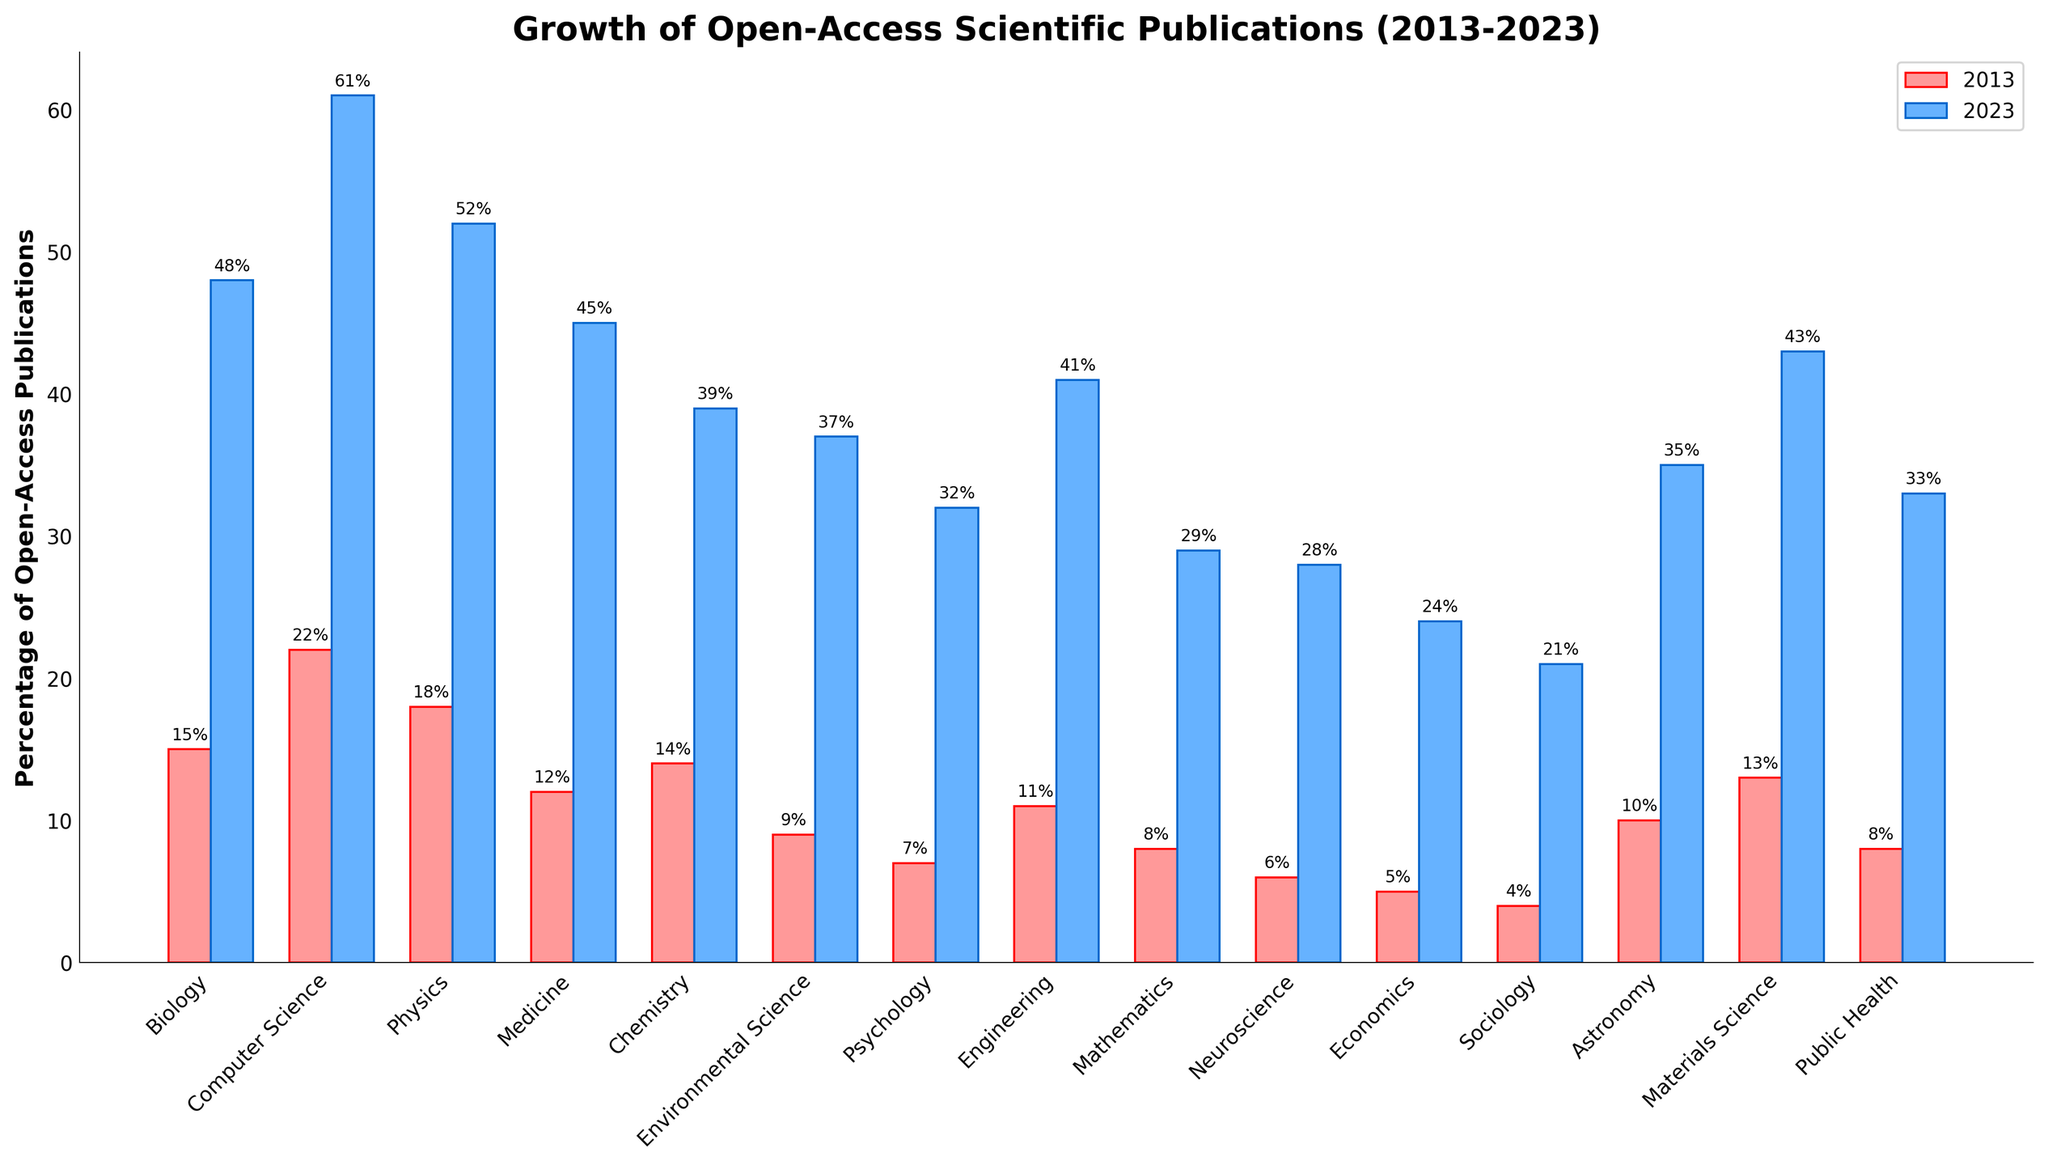What is the percentage increase in open-access publications for Computer Science from 2013 to 2023? Subtract the percentage in 2013 from the percentage in 2023. The values are 61% (2023) and 22% (2013). The increase is 61 - 22 = 39%.
Answer: 39% Which academic discipline had the highest percentage of open-access publications in 2013? Compare the heights of the red bars (2013) across all disciplines. The tallest red bar, representing 22%, is for Computer Science.
Answer: Computer Science Which discipline showed the smallest increase in open-access publications between 2013 and 2023? For each discipline, compute the difference between the 2023 and 2013 percentages, then identify the smallest difference. The increases are: Biology (33), Computer Science (39), Physics (34), Medicine (33), Chemistry (25), Environmental Science (28), Psychology (25), Engineering (30), Mathematics (21), Neuroscience (22), Economics (19), Sociology (17), Astronomy (25), Materials Science (30), Public Health (25). The smallest increase is 17 for Sociology.
Answer: Sociology What is the sum of the percentages of open-access publications for Medicine in 2013 and Economics in 2023? Add the percentages for Medicine in 2013 (12%) and Economics in 2023 (24%). The sum is 12 + 24 = 36.
Answer: 36% Which disciplines had fewer than 10% open-access publications in 2013? Identify the disciplines with red bars (2013) shorter than or equal to 10%. The bars for Psychology (7%), Mathematics (8%), Neuroscience (6%), Economics (5%), and Sociology (4%) meet this criterion.
Answer: Psychology, Mathematics, Neuroscience, Economics, Sociology How does the percentage growth for Public Health compare to Environmental Science? Calculate the difference for both disciplines: Public Health (33 - 8 = 25), Environmental Science (37 - 9 = 28). Environmental Science grew by 28% while Public Health grew by 25%. Environmental Science has a higher growth by 3%.
Answer: Environmental Science grew 3% more What is the average percentage of open-access publications for the top three disciplines in 2023? The top three disciplines in 2023 are Computer Science (61%), Biology (48%), Physics (52%). Calculate their average: (61 + 48 + 52) / 3 = 53.67.
Answer: 53.67% Which discipline had a more significant percentage increase: Engineering or Astronomy? Calculate the difference for both disciplines: Engineering (41 - 11 = 30), Astronomy (35 - 10 = 25). Engineering saw a 30% increase, which is larger than Astronomy's 25%.
Answer: Engineering Which discipline has the closest percentage of open-access publications in 2023 to Physics in 2013? Physics in 2013 is at 18%. In 2023, Neuroscience is at 28%, which is 10% away. The closest discipline percentage in 2023 to Physics in 2013 is identified by comparing distances. Mathematics at 29% in 2023 is a more precise match with a difference of 11%. Compare all values if needed.
Answer: Neuroscience (within 10%) Which two academic disciplines had the same increase in open-access publications between 2013 and 2023? Calculate the increase for each discipline and look for matches. The disciplines with matching differences are Chemistry (39 - 14 = 25) and Psychology (32 - 7 = 25).
Answer: Chemistry, Psychology 